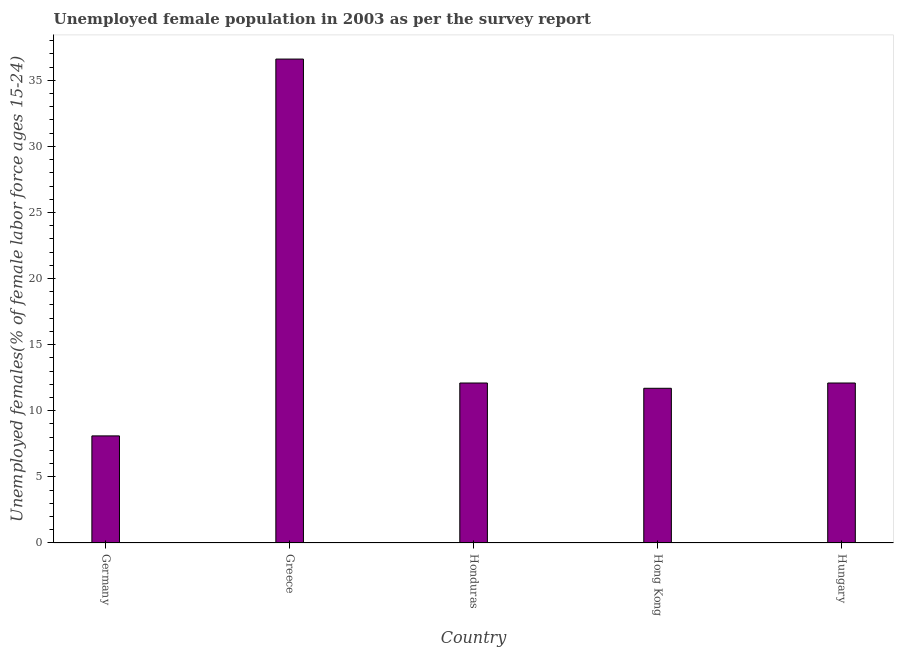Does the graph contain any zero values?
Ensure brevity in your answer.  No. What is the title of the graph?
Your answer should be compact. Unemployed female population in 2003 as per the survey report. What is the label or title of the Y-axis?
Keep it short and to the point. Unemployed females(% of female labor force ages 15-24). What is the unemployed female youth in Hong Kong?
Your answer should be compact. 11.7. Across all countries, what is the maximum unemployed female youth?
Give a very brief answer. 36.6. Across all countries, what is the minimum unemployed female youth?
Ensure brevity in your answer.  8.1. What is the sum of the unemployed female youth?
Keep it short and to the point. 80.6. What is the difference between the unemployed female youth in Greece and Hong Kong?
Offer a terse response. 24.9. What is the average unemployed female youth per country?
Offer a very short reply. 16.12. What is the median unemployed female youth?
Offer a terse response. 12.1. In how many countries, is the unemployed female youth greater than 20 %?
Make the answer very short. 1. What is the ratio of the unemployed female youth in Hong Kong to that in Hungary?
Ensure brevity in your answer.  0.97. Is the unemployed female youth in Greece less than that in Hungary?
Your response must be concise. No. Is the difference between the unemployed female youth in Germany and Greece greater than the difference between any two countries?
Offer a very short reply. Yes. Is the sum of the unemployed female youth in Greece and Hungary greater than the maximum unemployed female youth across all countries?
Your response must be concise. Yes. In how many countries, is the unemployed female youth greater than the average unemployed female youth taken over all countries?
Ensure brevity in your answer.  1. Are all the bars in the graph horizontal?
Offer a terse response. No. What is the Unemployed females(% of female labor force ages 15-24) in Germany?
Your response must be concise. 8.1. What is the Unemployed females(% of female labor force ages 15-24) of Greece?
Ensure brevity in your answer.  36.6. What is the Unemployed females(% of female labor force ages 15-24) of Honduras?
Offer a very short reply. 12.1. What is the Unemployed females(% of female labor force ages 15-24) of Hong Kong?
Give a very brief answer. 11.7. What is the Unemployed females(% of female labor force ages 15-24) of Hungary?
Provide a short and direct response. 12.1. What is the difference between the Unemployed females(% of female labor force ages 15-24) in Germany and Greece?
Your answer should be very brief. -28.5. What is the difference between the Unemployed females(% of female labor force ages 15-24) in Germany and Honduras?
Provide a short and direct response. -4. What is the difference between the Unemployed females(% of female labor force ages 15-24) in Germany and Hungary?
Make the answer very short. -4. What is the difference between the Unemployed females(% of female labor force ages 15-24) in Greece and Honduras?
Your answer should be compact. 24.5. What is the difference between the Unemployed females(% of female labor force ages 15-24) in Greece and Hong Kong?
Your answer should be very brief. 24.9. What is the difference between the Unemployed females(% of female labor force ages 15-24) in Greece and Hungary?
Offer a very short reply. 24.5. What is the ratio of the Unemployed females(% of female labor force ages 15-24) in Germany to that in Greece?
Your response must be concise. 0.22. What is the ratio of the Unemployed females(% of female labor force ages 15-24) in Germany to that in Honduras?
Your answer should be very brief. 0.67. What is the ratio of the Unemployed females(% of female labor force ages 15-24) in Germany to that in Hong Kong?
Your response must be concise. 0.69. What is the ratio of the Unemployed females(% of female labor force ages 15-24) in Germany to that in Hungary?
Provide a succinct answer. 0.67. What is the ratio of the Unemployed females(% of female labor force ages 15-24) in Greece to that in Honduras?
Your answer should be very brief. 3.02. What is the ratio of the Unemployed females(% of female labor force ages 15-24) in Greece to that in Hong Kong?
Provide a short and direct response. 3.13. What is the ratio of the Unemployed females(% of female labor force ages 15-24) in Greece to that in Hungary?
Give a very brief answer. 3.02. What is the ratio of the Unemployed females(% of female labor force ages 15-24) in Honduras to that in Hong Kong?
Offer a very short reply. 1.03. 